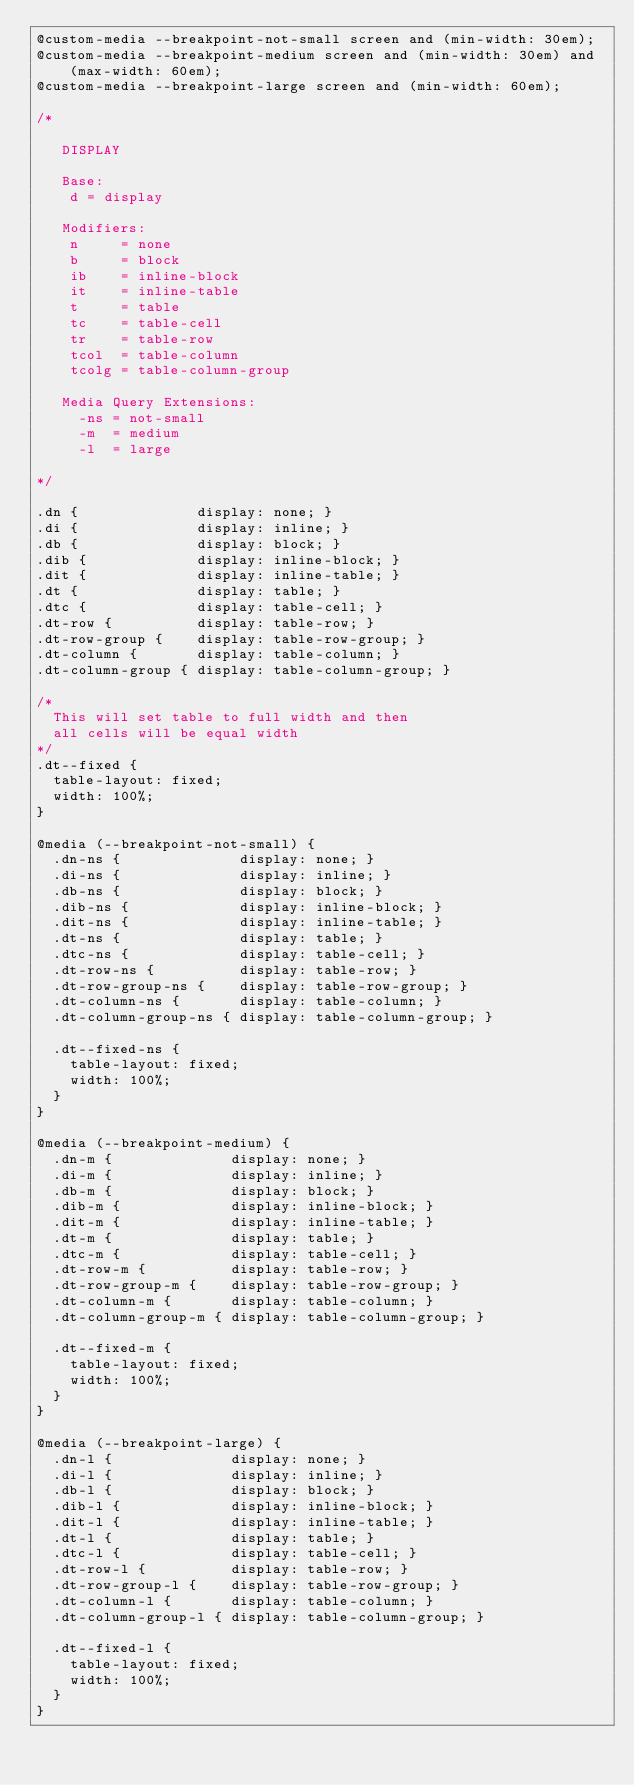Convert code to text. <code><loc_0><loc_0><loc_500><loc_500><_CSS_>@custom-media --breakpoint-not-small screen and (min-width: 30em);
@custom-media --breakpoint-medium screen and (min-width: 30em) and (max-width: 60em);
@custom-media --breakpoint-large screen and (min-width: 60em);

/*

   DISPLAY

   Base:
    d = display

   Modifiers:
    n     = none
    b     = block
    ib    = inline-block
    it    = inline-table
    t     = table
    tc    = table-cell
    tr    = table-row
    tcol  = table-column
    tcolg = table-column-group

   Media Query Extensions:
     -ns = not-small
     -m  = medium
     -l  = large

*/

.dn {              display: none; }
.di {              display: inline; }
.db {              display: block; }
.dib {             display: inline-block; }
.dit {             display: inline-table; }
.dt {              display: table; }
.dtc {             display: table-cell; }
.dt-row {          display: table-row; }
.dt-row-group {    display: table-row-group; }
.dt-column {       display: table-column; }
.dt-column-group { display: table-column-group; }

/*
  This will set table to full width and then
  all cells will be equal width
*/
.dt--fixed {
  table-layout: fixed;
  width: 100%;
}

@media (--breakpoint-not-small) {
  .dn-ns {              display: none; }
  .di-ns {              display: inline; }
  .db-ns {              display: block; }
  .dib-ns {             display: inline-block; }
  .dit-ns {             display: inline-table; }
  .dt-ns {              display: table; }
  .dtc-ns {             display: table-cell; }
  .dt-row-ns {          display: table-row; }
  .dt-row-group-ns {    display: table-row-group; }
  .dt-column-ns {       display: table-column; }
  .dt-column-group-ns { display: table-column-group; }

  .dt--fixed-ns {
    table-layout: fixed;
    width: 100%;
  }
}

@media (--breakpoint-medium) {
  .dn-m {              display: none; }
  .di-m {              display: inline; }
  .db-m {              display: block; }
  .dib-m {             display: inline-block; }
  .dit-m {             display: inline-table; }
  .dt-m {              display: table; }
  .dtc-m {             display: table-cell; }
  .dt-row-m {          display: table-row; }
  .dt-row-group-m {    display: table-row-group; }
  .dt-column-m {       display: table-column; }
  .dt-column-group-m { display: table-column-group; }

  .dt--fixed-m {
    table-layout: fixed;
    width: 100%;
  }
}

@media (--breakpoint-large) {
  .dn-l {              display: none; }
  .di-l {              display: inline; }
  .db-l {              display: block; }
  .dib-l {             display: inline-block; }
  .dit-l {             display: inline-table; }
  .dt-l {              display: table; }
  .dtc-l {             display: table-cell; }
  .dt-row-l {          display: table-row; }
  .dt-row-group-l {    display: table-row-group; }
  .dt-column-l {       display: table-column; }
  .dt-column-group-l { display: table-column-group; }

  .dt--fixed-l {
    table-layout: fixed;
    width: 100%;
  }
}

</code> 